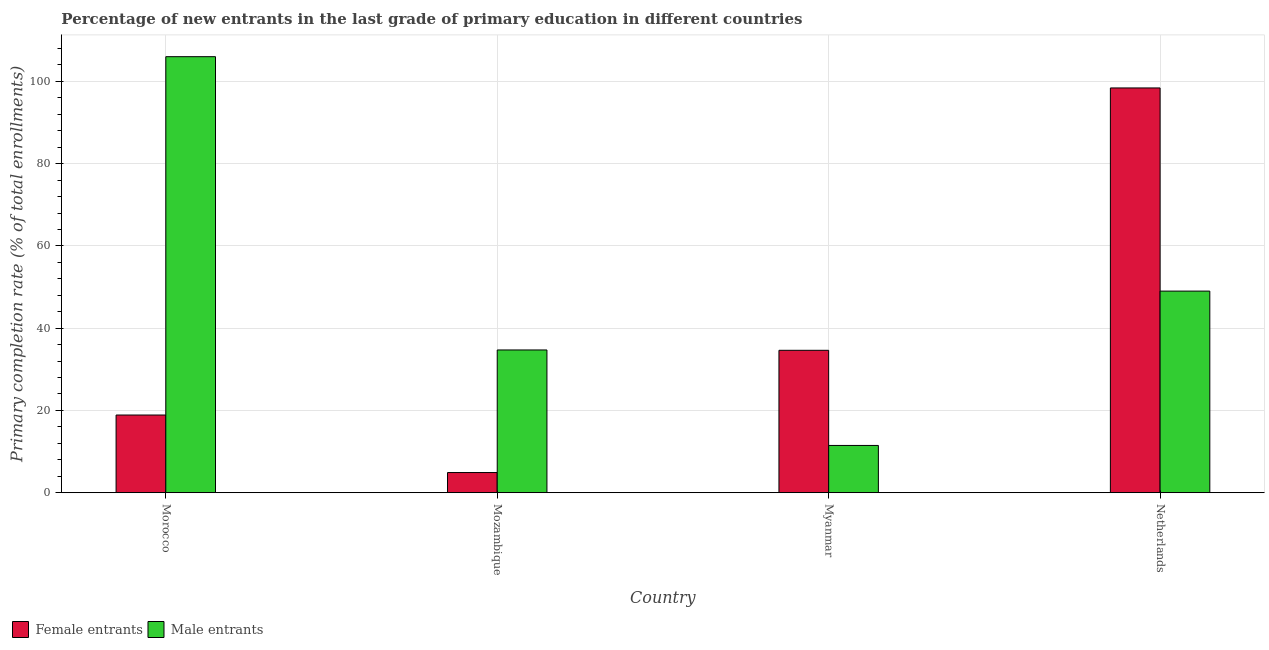How many groups of bars are there?
Give a very brief answer. 4. How many bars are there on the 2nd tick from the left?
Offer a terse response. 2. How many bars are there on the 2nd tick from the right?
Provide a short and direct response. 2. What is the label of the 1st group of bars from the left?
Give a very brief answer. Morocco. What is the primary completion rate of female entrants in Netherlands?
Give a very brief answer. 98.4. Across all countries, what is the maximum primary completion rate of male entrants?
Provide a succinct answer. 106.01. Across all countries, what is the minimum primary completion rate of female entrants?
Your answer should be very brief. 4.91. In which country was the primary completion rate of male entrants maximum?
Give a very brief answer. Morocco. In which country was the primary completion rate of female entrants minimum?
Your response must be concise. Mozambique. What is the total primary completion rate of male entrants in the graph?
Ensure brevity in your answer.  201.22. What is the difference between the primary completion rate of male entrants in Mozambique and that in Netherlands?
Provide a succinct answer. -14.31. What is the difference between the primary completion rate of male entrants in Netherlands and the primary completion rate of female entrants in Morocco?
Keep it short and to the point. 30.13. What is the average primary completion rate of female entrants per country?
Give a very brief answer. 39.2. What is the difference between the primary completion rate of female entrants and primary completion rate of male entrants in Morocco?
Offer a terse response. -87.12. What is the ratio of the primary completion rate of female entrants in Myanmar to that in Netherlands?
Ensure brevity in your answer.  0.35. Is the primary completion rate of male entrants in Mozambique less than that in Myanmar?
Make the answer very short. No. What is the difference between the highest and the second highest primary completion rate of female entrants?
Offer a terse response. 63.78. What is the difference between the highest and the lowest primary completion rate of male entrants?
Your answer should be very brief. 94.52. Is the sum of the primary completion rate of female entrants in Morocco and Mozambique greater than the maximum primary completion rate of male entrants across all countries?
Your response must be concise. No. What does the 2nd bar from the left in Netherlands represents?
Offer a terse response. Male entrants. What does the 2nd bar from the right in Mozambique represents?
Ensure brevity in your answer.  Female entrants. How many bars are there?
Offer a terse response. 8. Are all the bars in the graph horizontal?
Give a very brief answer. No. How many countries are there in the graph?
Provide a succinct answer. 4. Are the values on the major ticks of Y-axis written in scientific E-notation?
Provide a succinct answer. No. Does the graph contain grids?
Keep it short and to the point. Yes. Where does the legend appear in the graph?
Offer a terse response. Bottom left. How many legend labels are there?
Offer a terse response. 2. How are the legend labels stacked?
Your answer should be compact. Horizontal. What is the title of the graph?
Your answer should be very brief. Percentage of new entrants in the last grade of primary education in different countries. What is the label or title of the X-axis?
Keep it short and to the point. Country. What is the label or title of the Y-axis?
Ensure brevity in your answer.  Primary completion rate (% of total enrollments). What is the Primary completion rate (% of total enrollments) in Female entrants in Morocco?
Give a very brief answer. 18.89. What is the Primary completion rate (% of total enrollments) of Male entrants in Morocco?
Your answer should be compact. 106.01. What is the Primary completion rate (% of total enrollments) in Female entrants in Mozambique?
Make the answer very short. 4.91. What is the Primary completion rate (% of total enrollments) of Male entrants in Mozambique?
Your answer should be very brief. 34.7. What is the Primary completion rate (% of total enrollments) of Female entrants in Myanmar?
Provide a short and direct response. 34.62. What is the Primary completion rate (% of total enrollments) in Male entrants in Myanmar?
Give a very brief answer. 11.49. What is the Primary completion rate (% of total enrollments) in Female entrants in Netherlands?
Give a very brief answer. 98.4. What is the Primary completion rate (% of total enrollments) in Male entrants in Netherlands?
Your answer should be very brief. 49.02. Across all countries, what is the maximum Primary completion rate (% of total enrollments) in Female entrants?
Ensure brevity in your answer.  98.4. Across all countries, what is the maximum Primary completion rate (% of total enrollments) in Male entrants?
Offer a very short reply. 106.01. Across all countries, what is the minimum Primary completion rate (% of total enrollments) in Female entrants?
Offer a very short reply. 4.91. Across all countries, what is the minimum Primary completion rate (% of total enrollments) in Male entrants?
Your answer should be very brief. 11.49. What is the total Primary completion rate (% of total enrollments) in Female entrants in the graph?
Offer a terse response. 156.82. What is the total Primary completion rate (% of total enrollments) in Male entrants in the graph?
Provide a short and direct response. 201.22. What is the difference between the Primary completion rate (% of total enrollments) of Female entrants in Morocco and that in Mozambique?
Provide a short and direct response. 13.98. What is the difference between the Primary completion rate (% of total enrollments) of Male entrants in Morocco and that in Mozambique?
Provide a short and direct response. 71.3. What is the difference between the Primary completion rate (% of total enrollments) of Female entrants in Morocco and that in Myanmar?
Provide a short and direct response. -15.74. What is the difference between the Primary completion rate (% of total enrollments) in Male entrants in Morocco and that in Myanmar?
Offer a terse response. 94.52. What is the difference between the Primary completion rate (% of total enrollments) in Female entrants in Morocco and that in Netherlands?
Make the answer very short. -79.52. What is the difference between the Primary completion rate (% of total enrollments) in Male entrants in Morocco and that in Netherlands?
Offer a terse response. 56.99. What is the difference between the Primary completion rate (% of total enrollments) in Female entrants in Mozambique and that in Myanmar?
Make the answer very short. -29.72. What is the difference between the Primary completion rate (% of total enrollments) of Male entrants in Mozambique and that in Myanmar?
Provide a succinct answer. 23.21. What is the difference between the Primary completion rate (% of total enrollments) of Female entrants in Mozambique and that in Netherlands?
Give a very brief answer. -93.5. What is the difference between the Primary completion rate (% of total enrollments) of Male entrants in Mozambique and that in Netherlands?
Give a very brief answer. -14.31. What is the difference between the Primary completion rate (% of total enrollments) in Female entrants in Myanmar and that in Netherlands?
Offer a terse response. -63.78. What is the difference between the Primary completion rate (% of total enrollments) in Male entrants in Myanmar and that in Netherlands?
Offer a very short reply. -37.52. What is the difference between the Primary completion rate (% of total enrollments) of Female entrants in Morocco and the Primary completion rate (% of total enrollments) of Male entrants in Mozambique?
Provide a short and direct response. -15.82. What is the difference between the Primary completion rate (% of total enrollments) in Female entrants in Morocco and the Primary completion rate (% of total enrollments) in Male entrants in Myanmar?
Your response must be concise. 7.39. What is the difference between the Primary completion rate (% of total enrollments) in Female entrants in Morocco and the Primary completion rate (% of total enrollments) in Male entrants in Netherlands?
Your response must be concise. -30.13. What is the difference between the Primary completion rate (% of total enrollments) of Female entrants in Mozambique and the Primary completion rate (% of total enrollments) of Male entrants in Myanmar?
Ensure brevity in your answer.  -6.59. What is the difference between the Primary completion rate (% of total enrollments) of Female entrants in Mozambique and the Primary completion rate (% of total enrollments) of Male entrants in Netherlands?
Provide a succinct answer. -44.11. What is the difference between the Primary completion rate (% of total enrollments) in Female entrants in Myanmar and the Primary completion rate (% of total enrollments) in Male entrants in Netherlands?
Offer a very short reply. -14.39. What is the average Primary completion rate (% of total enrollments) in Female entrants per country?
Ensure brevity in your answer.  39.2. What is the average Primary completion rate (% of total enrollments) in Male entrants per country?
Offer a very short reply. 50.3. What is the difference between the Primary completion rate (% of total enrollments) of Female entrants and Primary completion rate (% of total enrollments) of Male entrants in Morocco?
Your answer should be very brief. -87.12. What is the difference between the Primary completion rate (% of total enrollments) in Female entrants and Primary completion rate (% of total enrollments) in Male entrants in Mozambique?
Keep it short and to the point. -29.8. What is the difference between the Primary completion rate (% of total enrollments) of Female entrants and Primary completion rate (% of total enrollments) of Male entrants in Myanmar?
Offer a terse response. 23.13. What is the difference between the Primary completion rate (% of total enrollments) of Female entrants and Primary completion rate (% of total enrollments) of Male entrants in Netherlands?
Your response must be concise. 49.39. What is the ratio of the Primary completion rate (% of total enrollments) of Female entrants in Morocco to that in Mozambique?
Offer a very short reply. 3.85. What is the ratio of the Primary completion rate (% of total enrollments) of Male entrants in Morocco to that in Mozambique?
Your answer should be very brief. 3.05. What is the ratio of the Primary completion rate (% of total enrollments) in Female entrants in Morocco to that in Myanmar?
Your answer should be very brief. 0.55. What is the ratio of the Primary completion rate (% of total enrollments) of Male entrants in Morocco to that in Myanmar?
Give a very brief answer. 9.22. What is the ratio of the Primary completion rate (% of total enrollments) in Female entrants in Morocco to that in Netherlands?
Your response must be concise. 0.19. What is the ratio of the Primary completion rate (% of total enrollments) of Male entrants in Morocco to that in Netherlands?
Offer a terse response. 2.16. What is the ratio of the Primary completion rate (% of total enrollments) in Female entrants in Mozambique to that in Myanmar?
Your answer should be very brief. 0.14. What is the ratio of the Primary completion rate (% of total enrollments) of Male entrants in Mozambique to that in Myanmar?
Your answer should be very brief. 3.02. What is the ratio of the Primary completion rate (% of total enrollments) of Female entrants in Mozambique to that in Netherlands?
Ensure brevity in your answer.  0.05. What is the ratio of the Primary completion rate (% of total enrollments) in Male entrants in Mozambique to that in Netherlands?
Provide a succinct answer. 0.71. What is the ratio of the Primary completion rate (% of total enrollments) in Female entrants in Myanmar to that in Netherlands?
Your answer should be compact. 0.35. What is the ratio of the Primary completion rate (% of total enrollments) in Male entrants in Myanmar to that in Netherlands?
Your answer should be compact. 0.23. What is the difference between the highest and the second highest Primary completion rate (% of total enrollments) of Female entrants?
Offer a terse response. 63.78. What is the difference between the highest and the second highest Primary completion rate (% of total enrollments) in Male entrants?
Offer a very short reply. 56.99. What is the difference between the highest and the lowest Primary completion rate (% of total enrollments) in Female entrants?
Provide a short and direct response. 93.5. What is the difference between the highest and the lowest Primary completion rate (% of total enrollments) of Male entrants?
Make the answer very short. 94.52. 